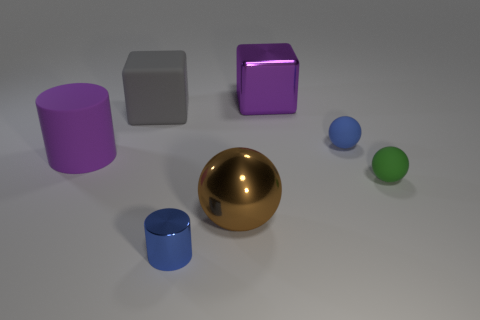Are there any purple blocks in front of the big cube that is on the right side of the ball that is left of the small blue matte object?
Your response must be concise. No. There is a tiny cylinder; does it have the same color as the small sphere that is behind the matte cylinder?
Provide a short and direct response. Yes. How many metal objects have the same color as the large cylinder?
Ensure brevity in your answer.  1. There is a cylinder that is on the right side of the block to the left of the purple cube; what size is it?
Your answer should be compact. Small. What number of objects are large metal things left of the big purple cube or shiny cylinders?
Your answer should be very brief. 2. Are there any blue spheres of the same size as the green ball?
Make the answer very short. Yes. Are there any large purple rubber cylinders that are on the right side of the matte thing that is behind the small blue matte thing?
Your answer should be very brief. No. How many spheres are either large blue things or big rubber objects?
Offer a very short reply. 0. Is there a purple matte thing of the same shape as the large purple metal thing?
Make the answer very short. No. The big brown object has what shape?
Offer a very short reply. Sphere. 